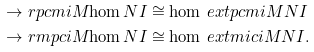<formula> <loc_0><loc_0><loc_500><loc_500>\to r p c m { i } { M } { \hom N I } & \cong \hom { \ e x t p c m { i } M N } { I } \\ \to r m p c { i } { M } { \hom N I } & \cong \hom { \ e x t m i c { i } M N } { I } .</formula> 